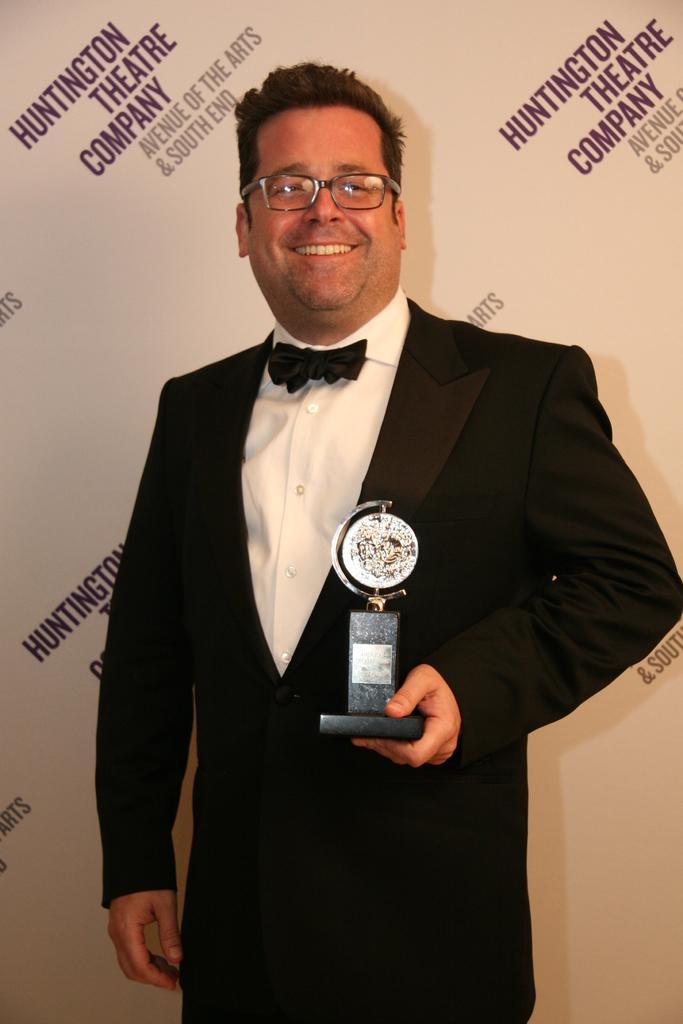In one or two sentences, can you explain what this image depicts? In this picture I can see a man in front who is standing and I see that he is wearing formal dress and he is smiling. I can also see that he is holding an award. In the background I can see the board on which there are words written. 